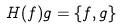<formula> <loc_0><loc_0><loc_500><loc_500>H ( f ) g = \{ f , g \}</formula> 